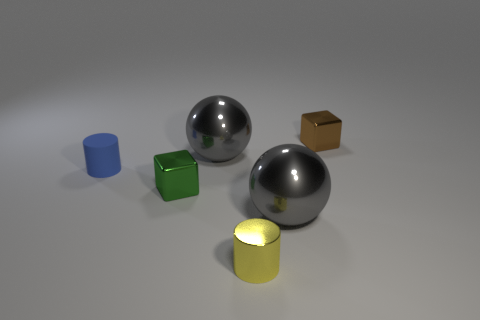What number of cylinders are either small blue rubber objects or brown shiny objects?
Offer a terse response. 1. What is the shape of the small metal object that is in front of the block that is left of the metallic block on the right side of the small shiny cylinder?
Offer a very short reply. Cylinder. How many green metal things have the same size as the yellow metallic cylinder?
Provide a short and direct response. 1. Is there a small blue thing to the left of the big gray shiny ball that is on the left side of the tiny metal cylinder?
Your answer should be compact. Yes. What number of things are big gray metallic spheres or tiny gray cylinders?
Ensure brevity in your answer.  2. The metallic object that is to the left of the big gray metal thing that is behind the small shiny cube to the left of the tiny brown metallic block is what color?
Provide a short and direct response. Green. Are there any other things that have the same color as the rubber cylinder?
Offer a very short reply. No. Do the blue cylinder and the yellow metal thing have the same size?
Ensure brevity in your answer.  Yes. How many objects are big metallic things on the left side of the yellow metal cylinder or gray metallic spheres behind the small green cube?
Offer a terse response. 1. There is a block behind the cube in front of the brown shiny block; what is it made of?
Your response must be concise. Metal. 